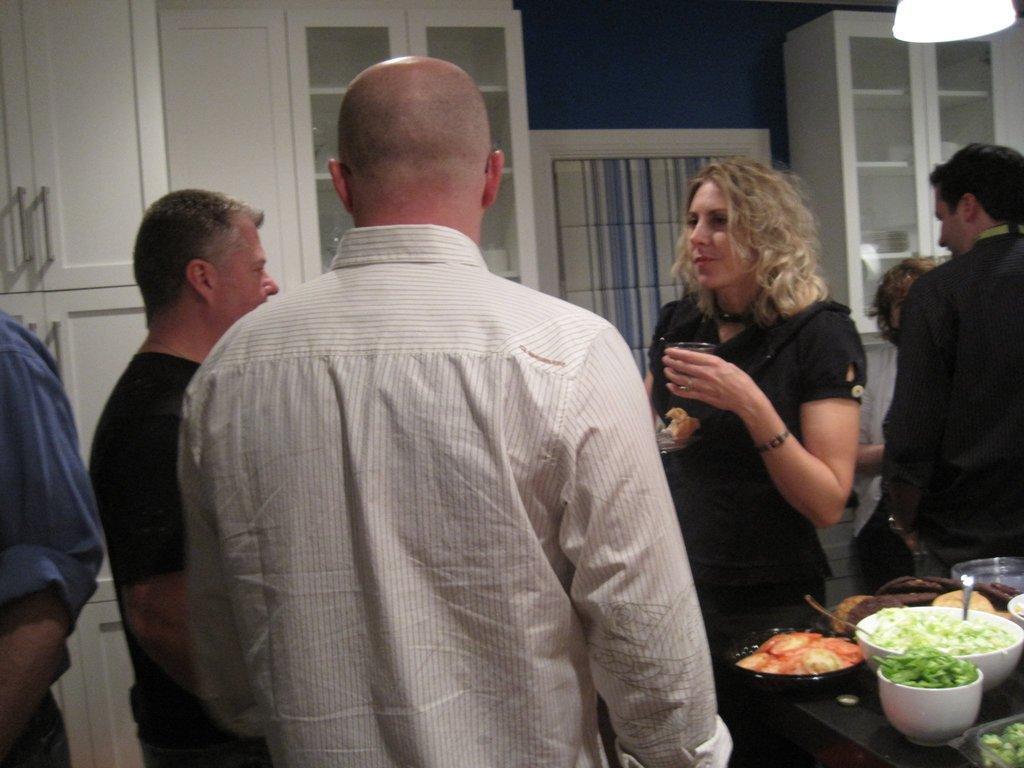Please provide a concise description of this image. In this image in the foreground there are some people who are standing, and in the foreground there is one woman who is holding a glass. At the bottom there is one table, on the table there are some plates, bowls and some spoons. In the plates and bowls there are some food items, in the background there is a wall, door and some cupboards. On the top of the right corner there is one light. 